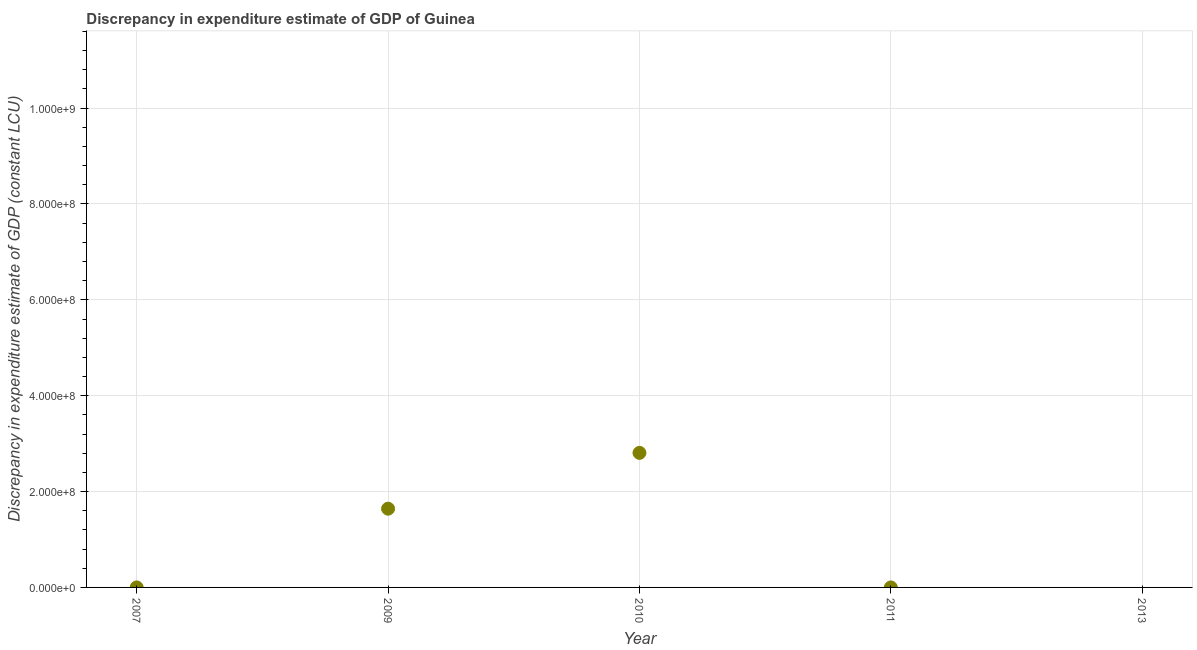What is the discrepancy in expenditure estimate of gdp in 2009?
Make the answer very short. 1.64e+08. Across all years, what is the maximum discrepancy in expenditure estimate of gdp?
Provide a succinct answer. 2.81e+08. Across all years, what is the minimum discrepancy in expenditure estimate of gdp?
Give a very brief answer. 0. In which year was the discrepancy in expenditure estimate of gdp maximum?
Provide a succinct answer. 2010. What is the sum of the discrepancy in expenditure estimate of gdp?
Make the answer very short. 4.45e+08. What is the difference between the discrepancy in expenditure estimate of gdp in 2007 and 2009?
Your answer should be very brief. -1.64e+08. What is the average discrepancy in expenditure estimate of gdp per year?
Ensure brevity in your answer.  8.90e+07. What is the ratio of the discrepancy in expenditure estimate of gdp in 2010 to that in 2011?
Make the answer very short. 2.81e+06. Is the difference between the discrepancy in expenditure estimate of gdp in 2007 and 2009 greater than the difference between any two years?
Ensure brevity in your answer.  No. What is the difference between the highest and the second highest discrepancy in expenditure estimate of gdp?
Ensure brevity in your answer.  1.16e+08. What is the difference between the highest and the lowest discrepancy in expenditure estimate of gdp?
Offer a terse response. 2.81e+08. How many dotlines are there?
Your answer should be compact. 1. How many years are there in the graph?
Provide a short and direct response. 5. Are the values on the major ticks of Y-axis written in scientific E-notation?
Offer a terse response. Yes. Does the graph contain any zero values?
Provide a short and direct response. Yes. What is the title of the graph?
Your answer should be compact. Discrepancy in expenditure estimate of GDP of Guinea. What is the label or title of the X-axis?
Ensure brevity in your answer.  Year. What is the label or title of the Y-axis?
Your answer should be very brief. Discrepancy in expenditure estimate of GDP (constant LCU). What is the Discrepancy in expenditure estimate of GDP (constant LCU) in 2007?
Your answer should be compact. 100. What is the Discrepancy in expenditure estimate of GDP (constant LCU) in 2009?
Make the answer very short. 1.64e+08. What is the Discrepancy in expenditure estimate of GDP (constant LCU) in 2010?
Give a very brief answer. 2.81e+08. What is the Discrepancy in expenditure estimate of GDP (constant LCU) in 2013?
Provide a short and direct response. 0. What is the difference between the Discrepancy in expenditure estimate of GDP (constant LCU) in 2007 and 2009?
Provide a short and direct response. -1.64e+08. What is the difference between the Discrepancy in expenditure estimate of GDP (constant LCU) in 2007 and 2010?
Offer a terse response. -2.81e+08. What is the difference between the Discrepancy in expenditure estimate of GDP (constant LCU) in 2009 and 2010?
Your response must be concise. -1.16e+08. What is the difference between the Discrepancy in expenditure estimate of GDP (constant LCU) in 2009 and 2011?
Keep it short and to the point. 1.64e+08. What is the difference between the Discrepancy in expenditure estimate of GDP (constant LCU) in 2010 and 2011?
Keep it short and to the point. 2.81e+08. What is the ratio of the Discrepancy in expenditure estimate of GDP (constant LCU) in 2007 to that in 2009?
Give a very brief answer. 0. What is the ratio of the Discrepancy in expenditure estimate of GDP (constant LCU) in 2007 to that in 2010?
Keep it short and to the point. 0. What is the ratio of the Discrepancy in expenditure estimate of GDP (constant LCU) in 2007 to that in 2011?
Keep it short and to the point. 1. What is the ratio of the Discrepancy in expenditure estimate of GDP (constant LCU) in 2009 to that in 2010?
Provide a succinct answer. 0.58. What is the ratio of the Discrepancy in expenditure estimate of GDP (constant LCU) in 2009 to that in 2011?
Provide a short and direct response. 1.64e+06. What is the ratio of the Discrepancy in expenditure estimate of GDP (constant LCU) in 2010 to that in 2011?
Provide a short and direct response. 2.81e+06. 